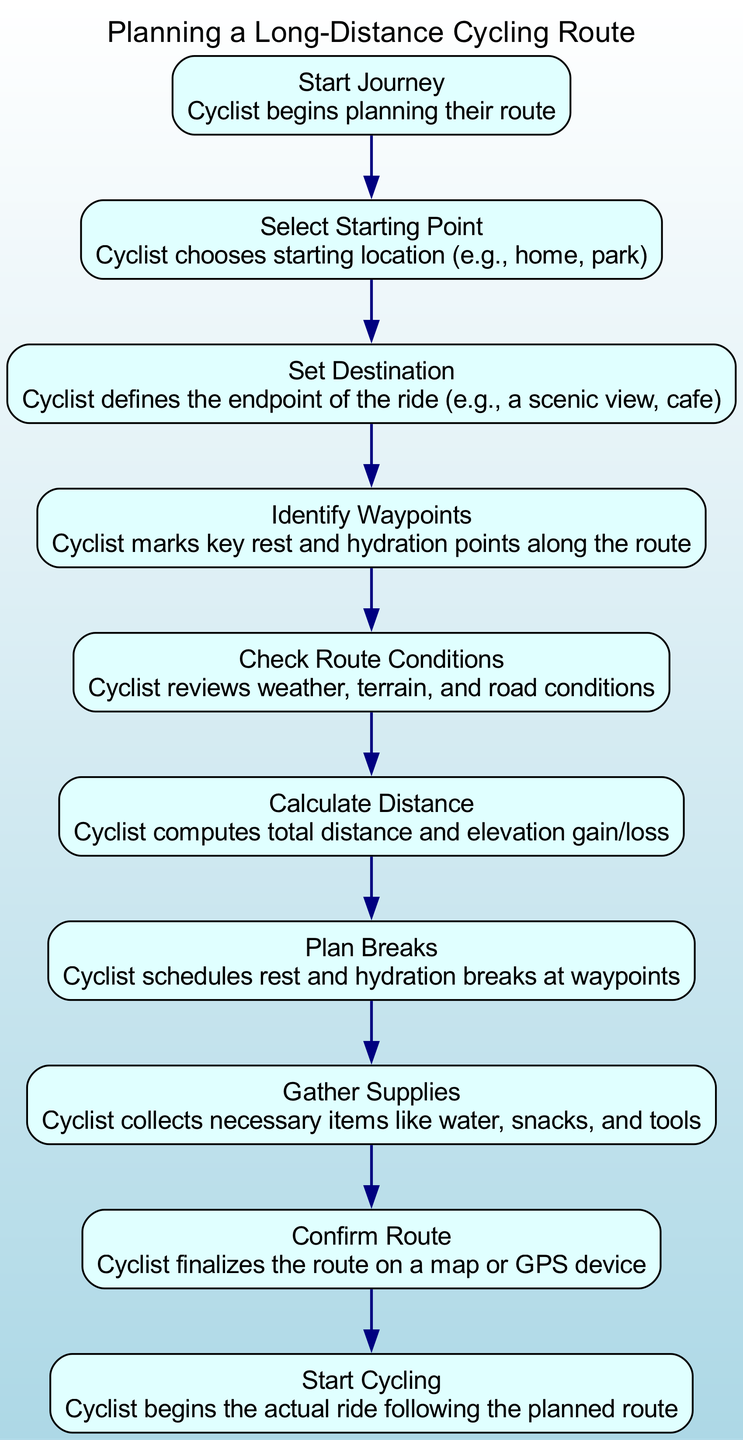What is the first step in planning a cycling route? The diagram indicates that the first action is labeled "Start Journey," which signifies the beginning of the route planning process.
Answer: Start Journey How many elements are part of the route planning sequence? By counting the individual steps listed in the sequence, there are a total of ten elements outlined.
Answer: Ten What is the final action after confirming the route? The sequence shows that the last action taken after confirming the route is to "Start Cycling."
Answer: Start Cycling Which element involves scheduling rest breaks? The element labeled "Plan Breaks" specifically pertains to scheduling rest and hydration breaks at identified waypoints.
Answer: Plan Breaks In what order do the actions occur after setting the destination? Following "Set Destination," the next actions are "Identify Waypoints," then "Check Route Conditions," and subsequently "Calculate Distance," in that exact order.
Answer: Identify Waypoints, Check Route Conditions, Calculate Distance What is the purpose of the "Gather Supplies" step? This step is aimed at collecting necessary items such as water, snacks, and tools, preparing the cyclist for the journey ahead.
Answer: Collecting necessary items What conditions are assessed after identifying waypoints? The cyclist reviews "weather, terrain, and road conditions" immediately after marking the waypoints to ensure a safe ride.
Answer: Weather, terrain, and road conditions Which node directly follows "Calculate Distance"? The node that directly follows "Calculate Distance" is "Plan Breaks," indicating the scheduling of rest and hydration moments after assessing the ride's length.
Answer: Plan Breaks Is the waypoints identification step before or after gathering supplies? According to the sequence, the "Identify Waypoints" step occurs before "Gather Supplies," as it is essential to plan where to rest and hydrate first.
Answer: Before 